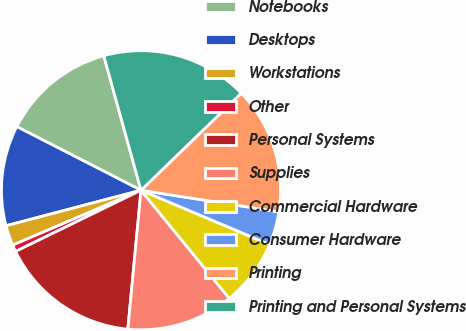<chart> <loc_0><loc_0><loc_500><loc_500><pie_chart><fcel>Notebooks<fcel>Desktops<fcel>Workstations<fcel>Other<fcel>Personal Systems<fcel>Supplies<fcel>Commercial Hardware<fcel>Consumer Hardware<fcel>Printing<fcel>Printing and Personal Systems<nl><fcel>13.17%<fcel>11.63%<fcel>2.34%<fcel>0.79%<fcel>16.27%<fcel>12.4%<fcel>7.75%<fcel>3.88%<fcel>14.72%<fcel>17.05%<nl></chart> 